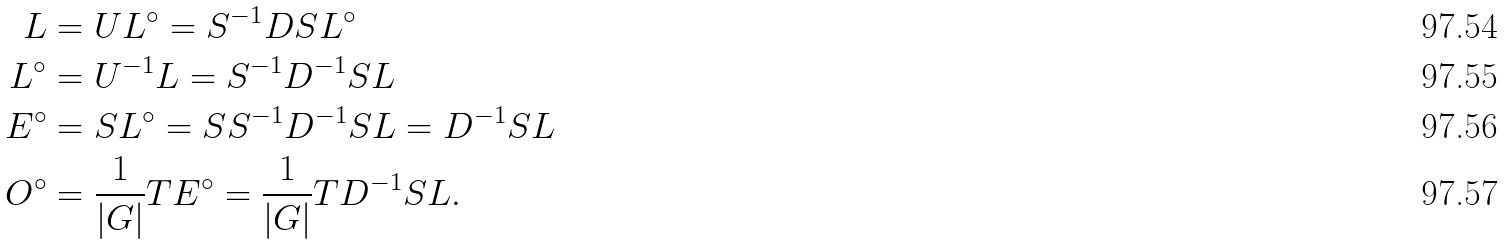<formula> <loc_0><loc_0><loc_500><loc_500>L & = U L ^ { \circ } = S ^ { - 1 } D S L ^ { \circ } \\ L ^ { \circ } & = U ^ { - 1 } L = S ^ { - 1 } D ^ { - 1 } S L \\ E ^ { \circ } & = S L ^ { \circ } = S S ^ { - 1 } D ^ { - 1 } S L = D ^ { - 1 } S L \\ O ^ { \circ } & = \frac { 1 } { \left | G \right | } T E ^ { \circ } = \frac { 1 } { \left | G \right | } T D ^ { - 1 } S L .</formula> 